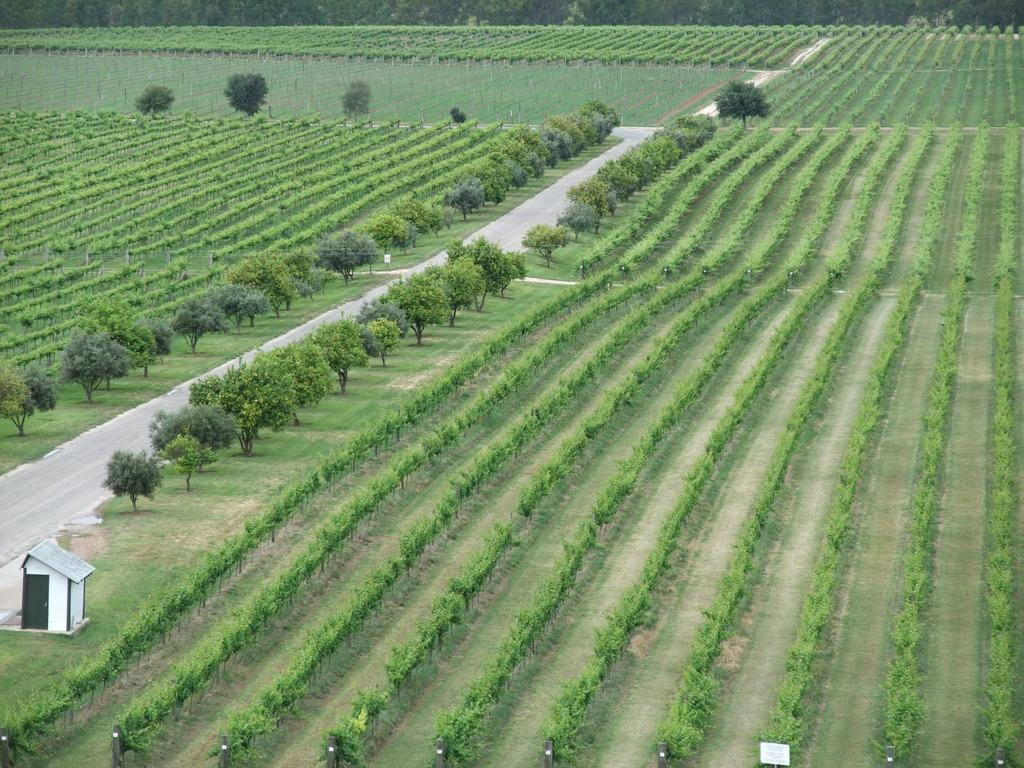What type of natural elements can be seen in the image? There are trees and plants in the image. What man-made structures are present in the image? There are poles, boards, and a shed in the image. What type of pathway is visible in the image? There is a road visible in the image. How does the taste of the trees affect the plants in the image? The taste of the trees does not affect the plants in the image, as taste is a sensory experience for humans and animals, not for plants. 